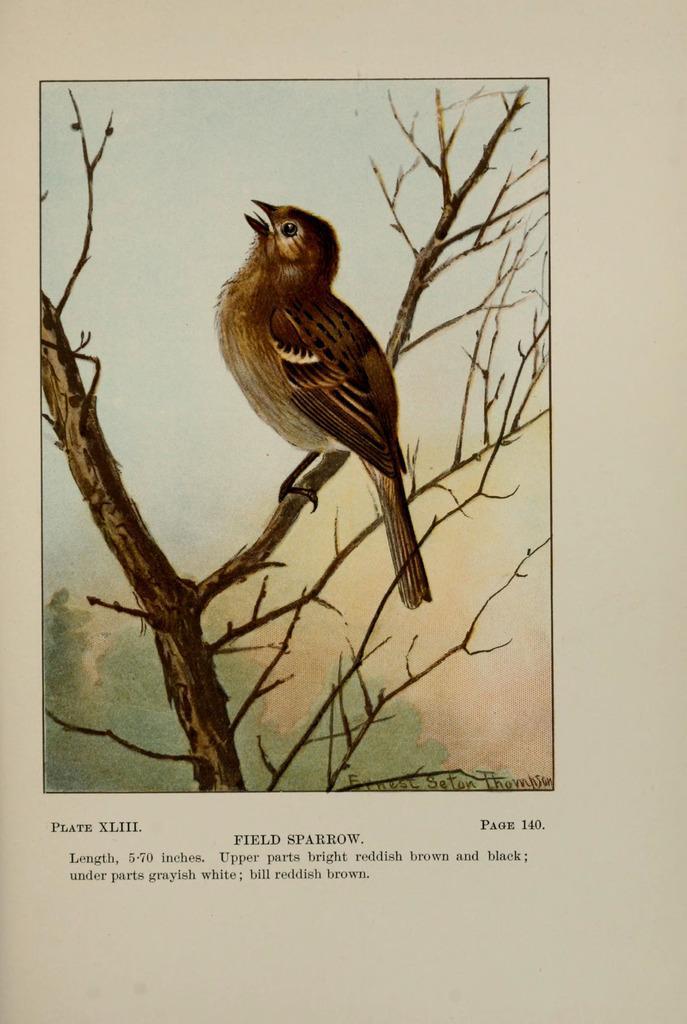Could you give a brief overview of what you see in this image? In the center of the image a bird is sitting on a branch. At the bottom of the image text is present. 